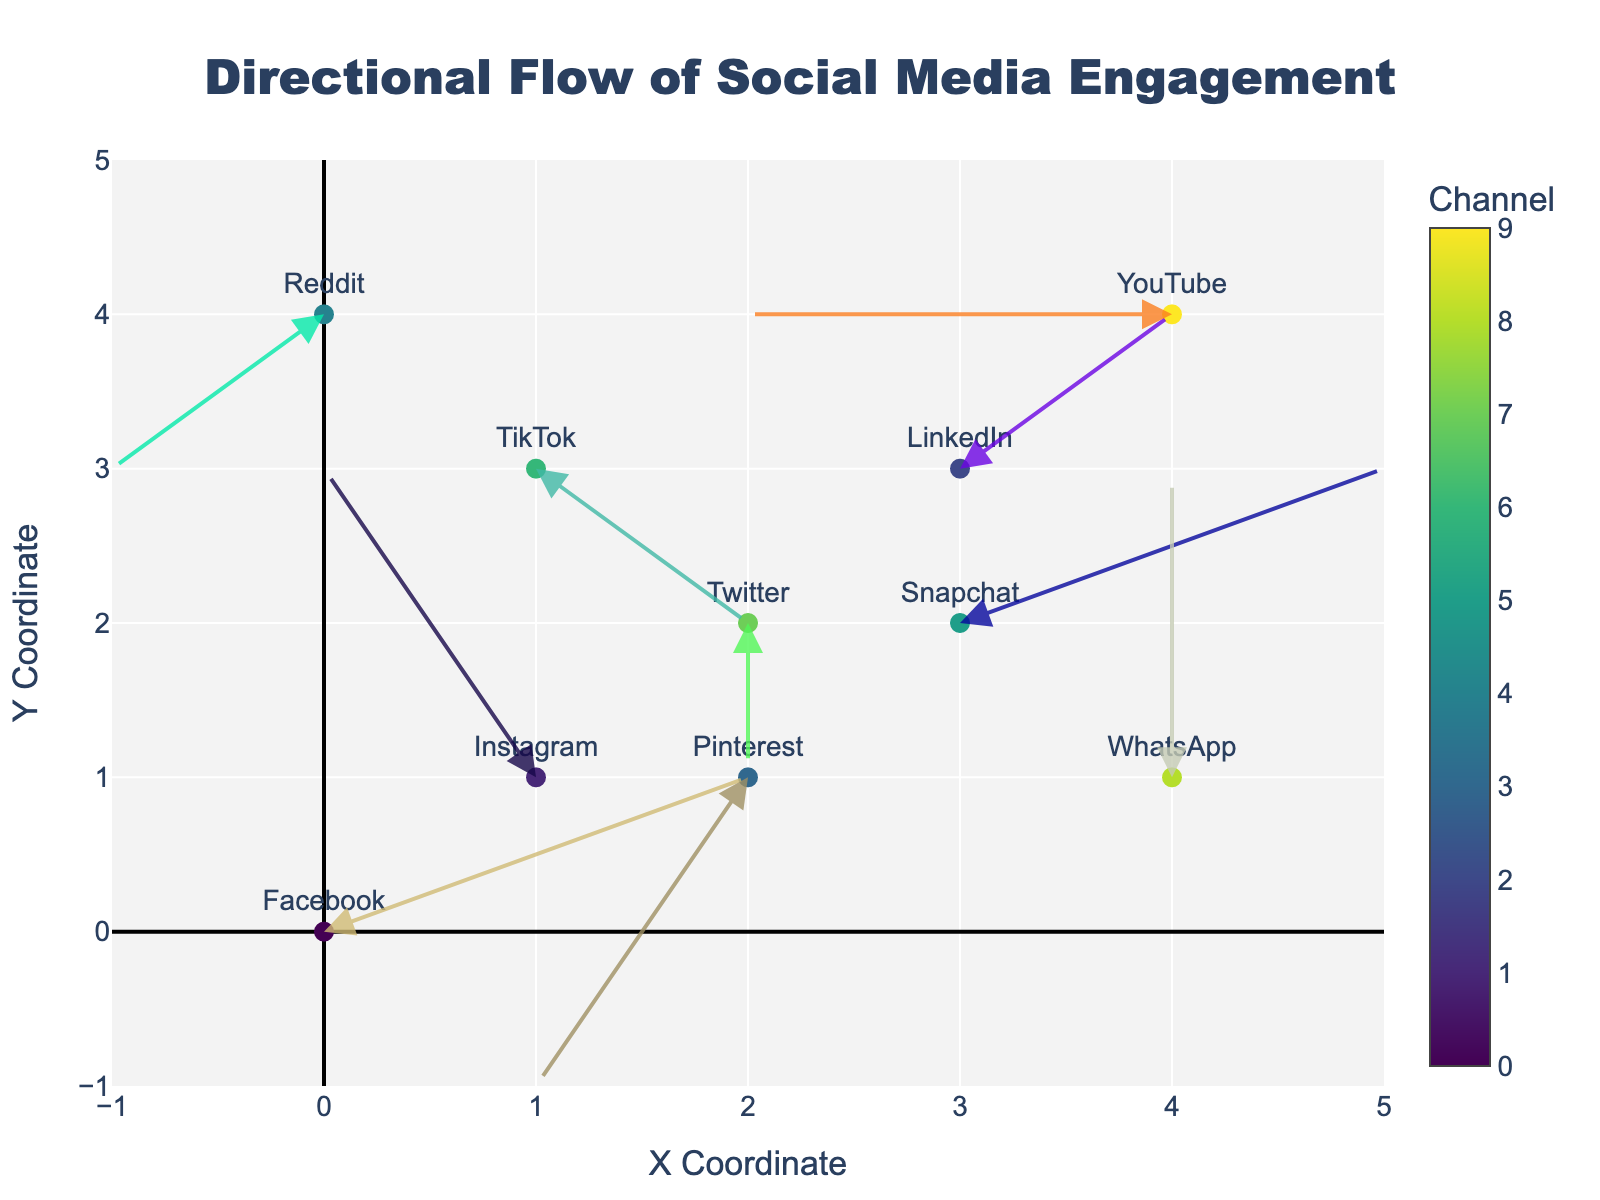What is the title of the figure? The title of the figure is displayed at the top and center of the plot. It is "Directional Flow of Social Media Engagement".
Answer: Directional Flow of Social Media Engagement How many marketing channels are represented in the plot? Each marker in the plot corresponds to a different marketing channel, and there are a total of 10 markers labeled with social media platforms.
Answer: 10 Which marketing channel has the highest vertical movement (y-direction) in the positive direction? To determine the highest vertical movement in the positive direction, look at the quiver arrows and find the one with the maximum positive y-component. The arrow for Instagram (at coordinates (1, 1)) moves the highest vertically in the positive direction (+2).
Answer: Instagram Which channel's engagement flow moves entirely to the left without changing vertical position? Examine the arrows and find the one with negative x-movement and zero y-movement. YouTube, at coordinates (4, 4), has an arrow that moves entirely to the left (-2, 0).
Answer: YouTube Which platform shows a decrease in both x and y directions? Look at the quiver arrows and find the one with negative values in both x and y directions. Pinterest, at coordinates (2, 1), shows movement in the negative direction for both x and y (-1, -2).
Answer: Pinterest Compare the movements of TikTok and LinkedIn. Which one has a stronger overall movement? Calculate the magnitude of the movement for both channels. TikTok's movement vector is (1, -1) and LinkedIn's vector is (1, 1). The magnitude is calculated as √(x² + y²). Both have a magnitude of √(1² + 1²) = √2 ≈ 1.41. Thus, their movements are equal.
Answer: Equal Which channel starts from the origin and what is its subsequent movement? Find the marker that starts at the origin (0, 0). The channel starting there is Facebook, with an arrow moving (2, 1).
Answer: Facebook; (2, 1) What is the total displacement of Snapchat from its starting point? The movement vector for Snapchat is (2, 1) starting from (3, 2). Calculate the displacement magnitude with √(2² + 1²) = √5 ≈ 2.24.
Answer: 2.24 Is Reddit's engagement flow moving towards the origin or away from it? Reddit starts at (0, 4) with an arrow moving (-1, -1). Since the arrow moves the point further from the origin (0, 0), the flow is moving away from the origin.
Answer: Away from it Which channel has a neutral x-direction movement and what is its y-component? Look for the arrow with a zero x-component. Twitter at (2, 2) moves only in the y-direction (-1).
Answer: Twitter; -1 